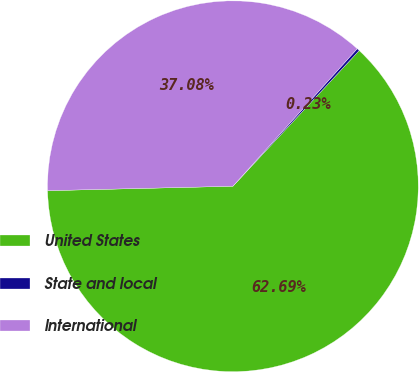<chart> <loc_0><loc_0><loc_500><loc_500><pie_chart><fcel>United States<fcel>State and local<fcel>International<nl><fcel>62.69%<fcel>0.23%<fcel>37.08%<nl></chart> 